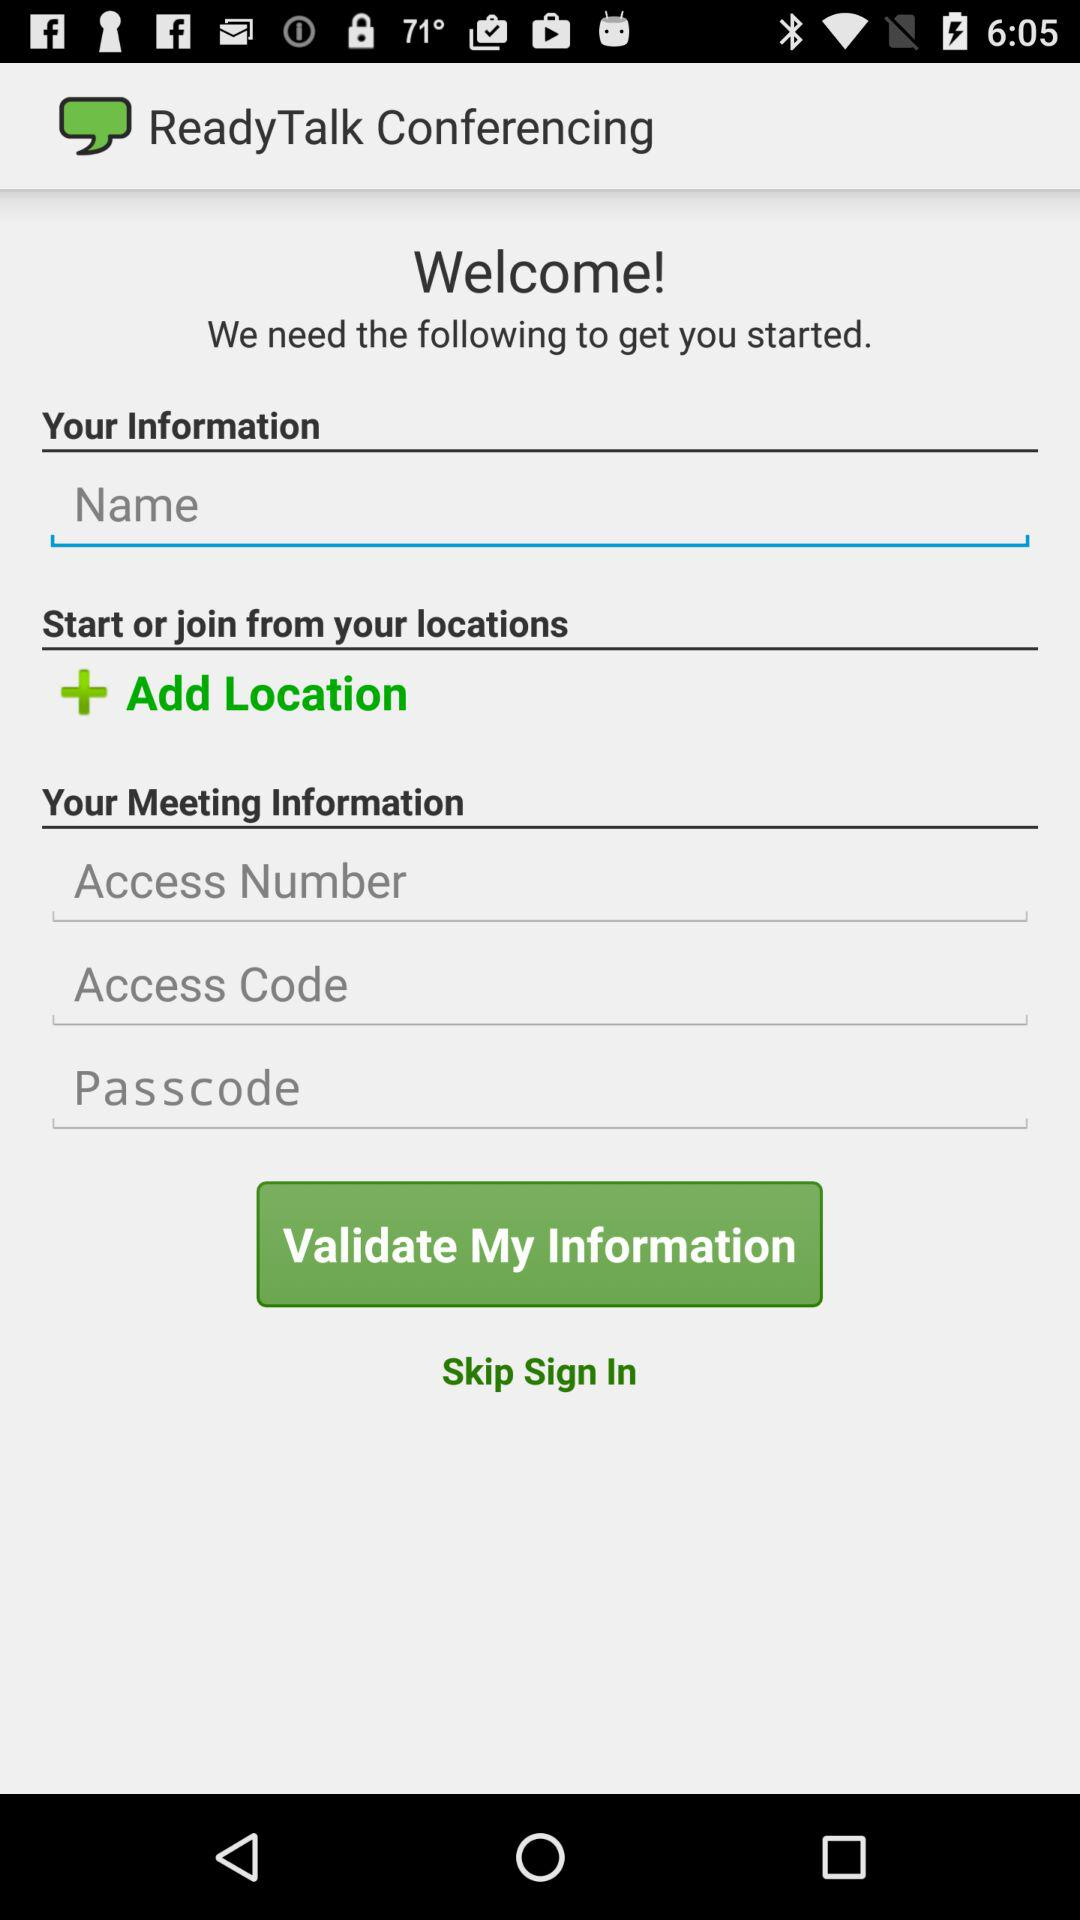How many text inputs are there for your meeting information?
Answer the question using a single word or phrase. 3 